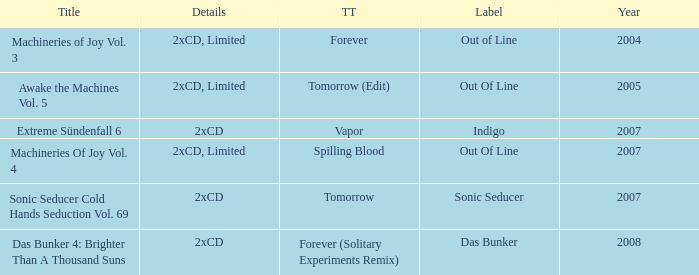Which track title has a year lesser thsn 2005? Forever. 